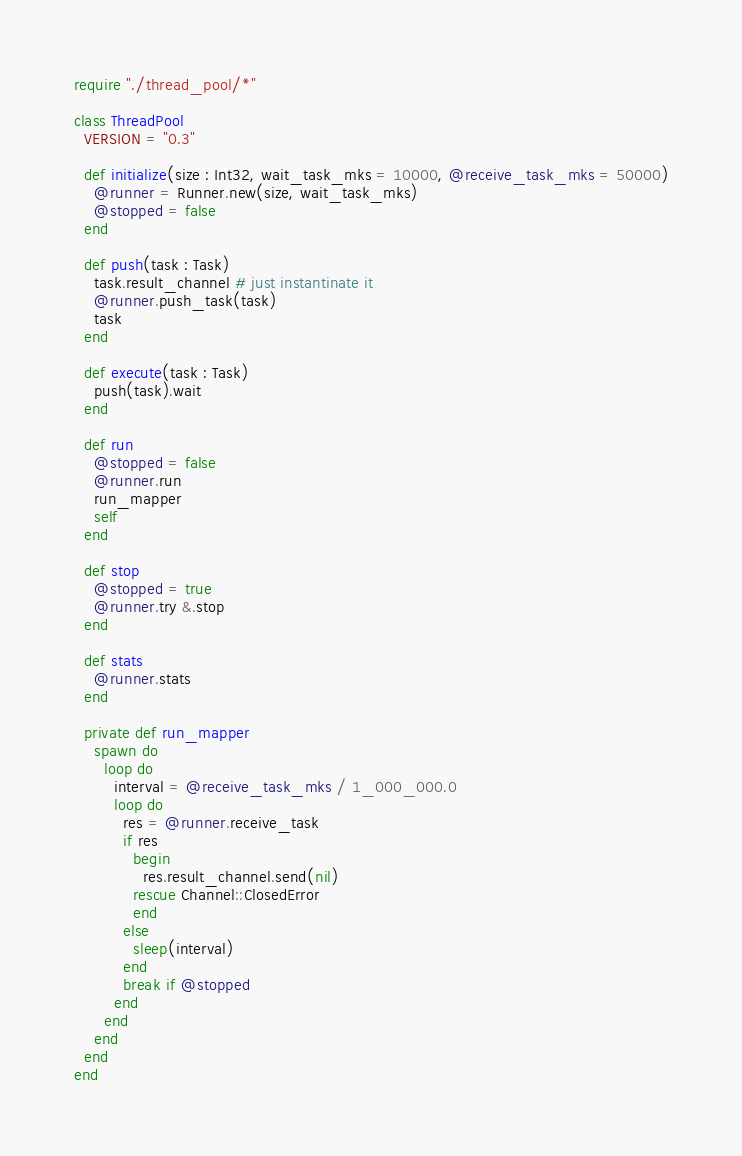<code> <loc_0><loc_0><loc_500><loc_500><_Crystal_>require "./thread_pool/*"

class ThreadPool
  VERSION = "0.3"

  def initialize(size : Int32, wait_task_mks = 10000, @receive_task_mks = 50000)
    @runner = Runner.new(size, wait_task_mks)
    @stopped = false
  end

  def push(task : Task)
    task.result_channel # just instantinate it
    @runner.push_task(task)
    task
  end

  def execute(task : Task)
    push(task).wait
  end

  def run
    @stopped = false
    @runner.run
    run_mapper
    self
  end

  def stop
    @stopped = true
    @runner.try &.stop
  end

  def stats
    @runner.stats
  end

  private def run_mapper
    spawn do
      loop do
        interval = @receive_task_mks / 1_000_000.0
        loop do
          res = @runner.receive_task
          if res
            begin
              res.result_channel.send(nil)
            rescue Channel::ClosedError
            end
          else
            sleep(interval)
          end
          break if @stopped
        end
      end
    end
  end
end
</code> 